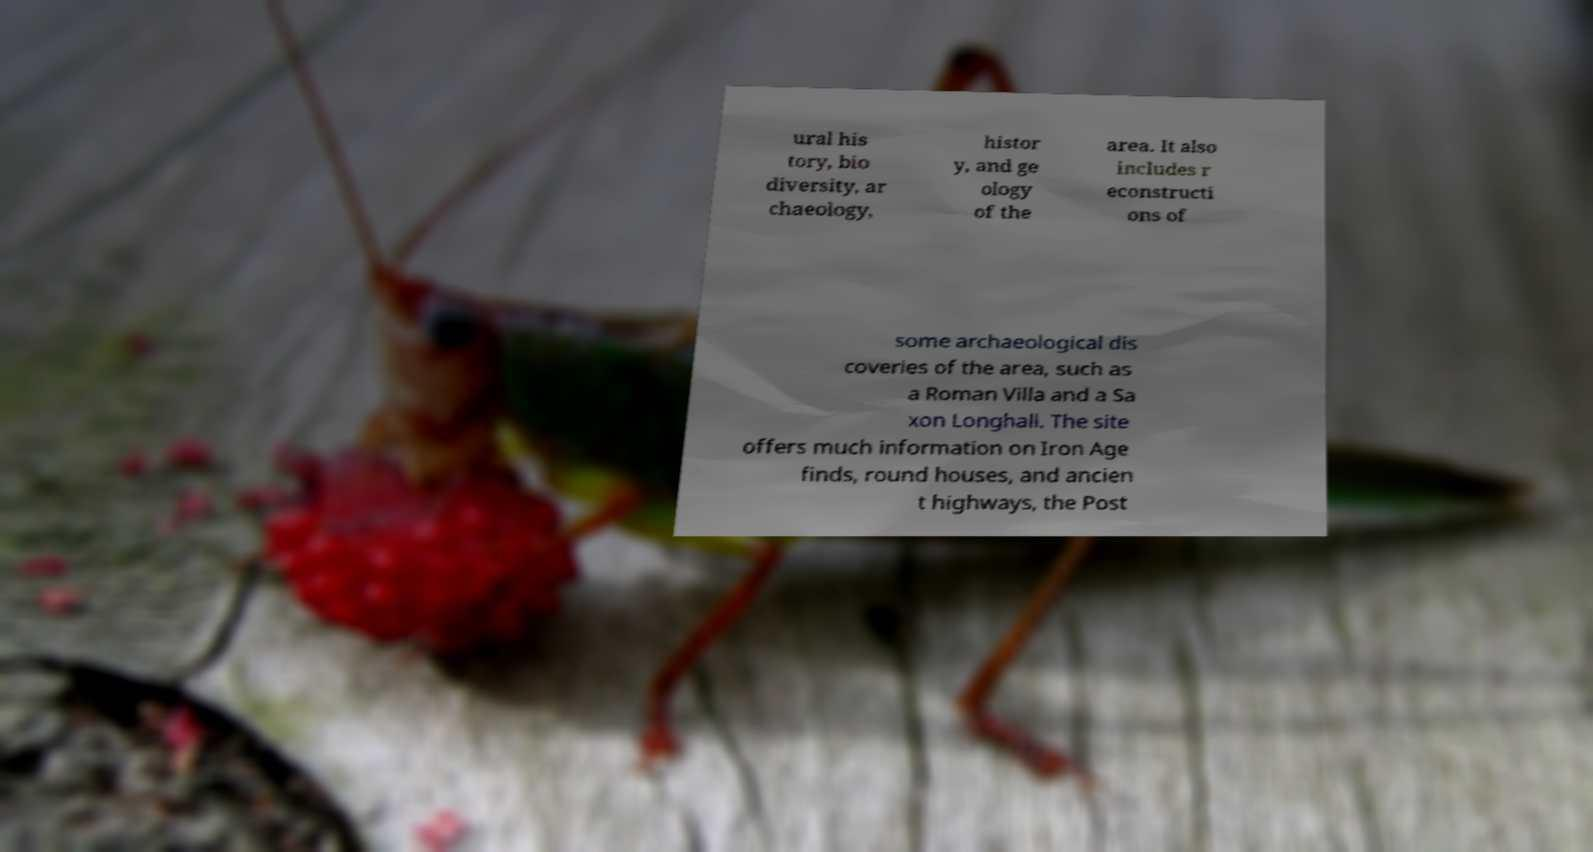Can you read and provide the text displayed in the image?This photo seems to have some interesting text. Can you extract and type it out for me? ural his tory, bio diversity, ar chaeology, histor y, and ge ology of the area. It also includes r econstructi ons of some archaeological dis coveries of the area, such as a Roman Villa and a Sa xon Longhall. The site offers much information on Iron Age finds, round houses, and ancien t highways, the Post 